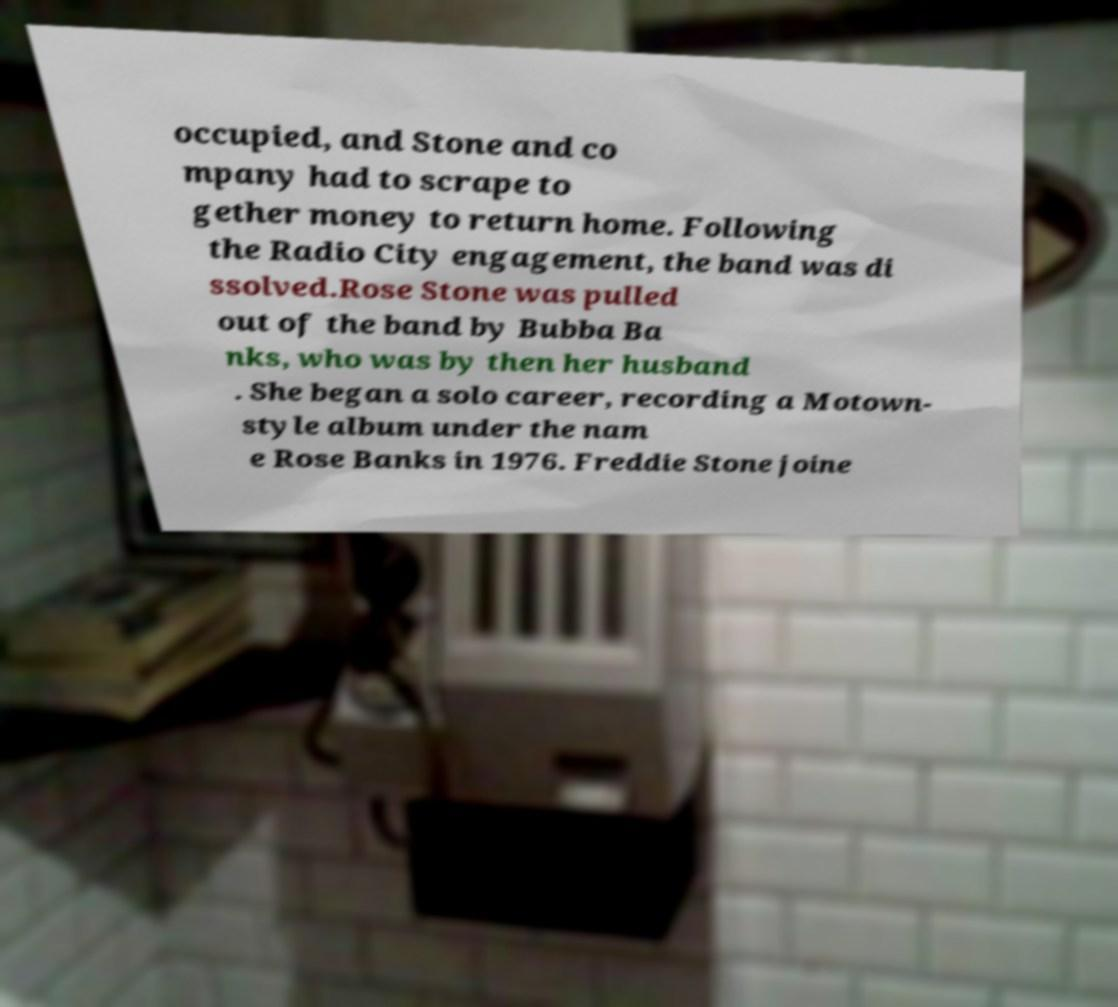For documentation purposes, I need the text within this image transcribed. Could you provide that? occupied, and Stone and co mpany had to scrape to gether money to return home. Following the Radio City engagement, the band was di ssolved.Rose Stone was pulled out of the band by Bubba Ba nks, who was by then her husband . She began a solo career, recording a Motown- style album under the nam e Rose Banks in 1976. Freddie Stone joine 